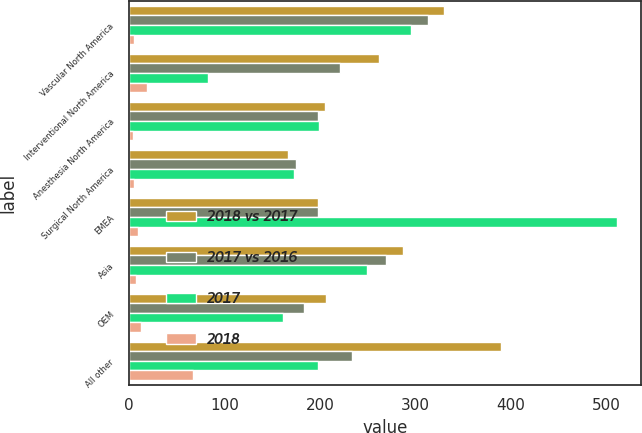Convert chart. <chart><loc_0><loc_0><loc_500><loc_500><stacked_bar_chart><ecel><fcel>Vascular North America<fcel>Interventional North America<fcel>Anesthesia North America<fcel>Surgical North America<fcel>EMEA<fcel>Asia<fcel>OEM<fcel>All other<nl><fcel>2018 vs 2017<fcel>329.5<fcel>261.6<fcel>205.1<fcel>166.3<fcel>198.05<fcel>286.9<fcel>206<fcel>389.2<nl><fcel>2017 vs 2016<fcel>313.6<fcel>220.6<fcel>198<fcel>175.2<fcel>198.05<fcel>269.2<fcel>183<fcel>234<nl><fcel>2017<fcel>295.2<fcel>82.4<fcel>198.8<fcel>172.2<fcel>510.9<fcel>249.4<fcel>161<fcel>198.1<nl><fcel>2018<fcel>5.1<fcel>18.6<fcel>3.6<fcel>5.1<fcel>9.2<fcel>6.6<fcel>12.6<fcel>66.4<nl></chart> 